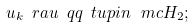Convert formula to latex. <formula><loc_0><loc_0><loc_500><loc_500>u _ { k } \ r a u \ q q \ t u p { i n } \, \ m c H _ { 2 } ;</formula> 